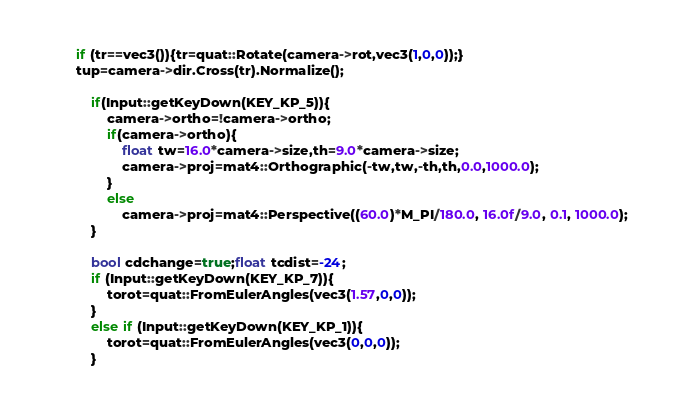Convert code to text. <code><loc_0><loc_0><loc_500><loc_500><_C++_>        if (tr==vec3()){tr=quat::Rotate(camera->rot,vec3(1,0,0));}
        tup=camera->dir.Cross(tr).Normalize();
        
            if(Input::getKeyDown(KEY_KP_5)){
                camera->ortho=!camera->ortho;
                if(camera->ortho){
                    float tw=16.0*camera->size,th=9.0*camera->size;
                    camera->proj=mat4::Orthographic(-tw,tw,-th,th,0.0,1000.0);
                }
                else
                    camera->proj=mat4::Perspective((60.0)*M_PI/180.0, 16.0f/9.0, 0.1, 1000.0);
            }
        
            bool cdchange=true;float tcdist=-24;
            if (Input::getKeyDown(KEY_KP_7)){
                torot=quat::FromEulerAngles(vec3(1.57,0,0));
            }
            else if (Input::getKeyDown(KEY_KP_1)){
                torot=quat::FromEulerAngles(vec3(0,0,0));
            }</code> 